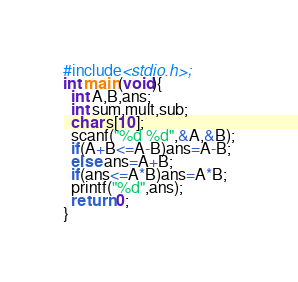Convert code to text. <code><loc_0><loc_0><loc_500><loc_500><_C++_>#include<stdio.h>;
int main(void){
  int A,B,ans;
  int sum,mult,sub;
  char s[10];
  scanf("%d %d",&A,&B);
  if(A+B<=A-B)ans=A-B;
  else ans=A+B;
  if(ans<=A*B)ans=A*B;
  printf("%d",ans);
  return 0;
}</code> 